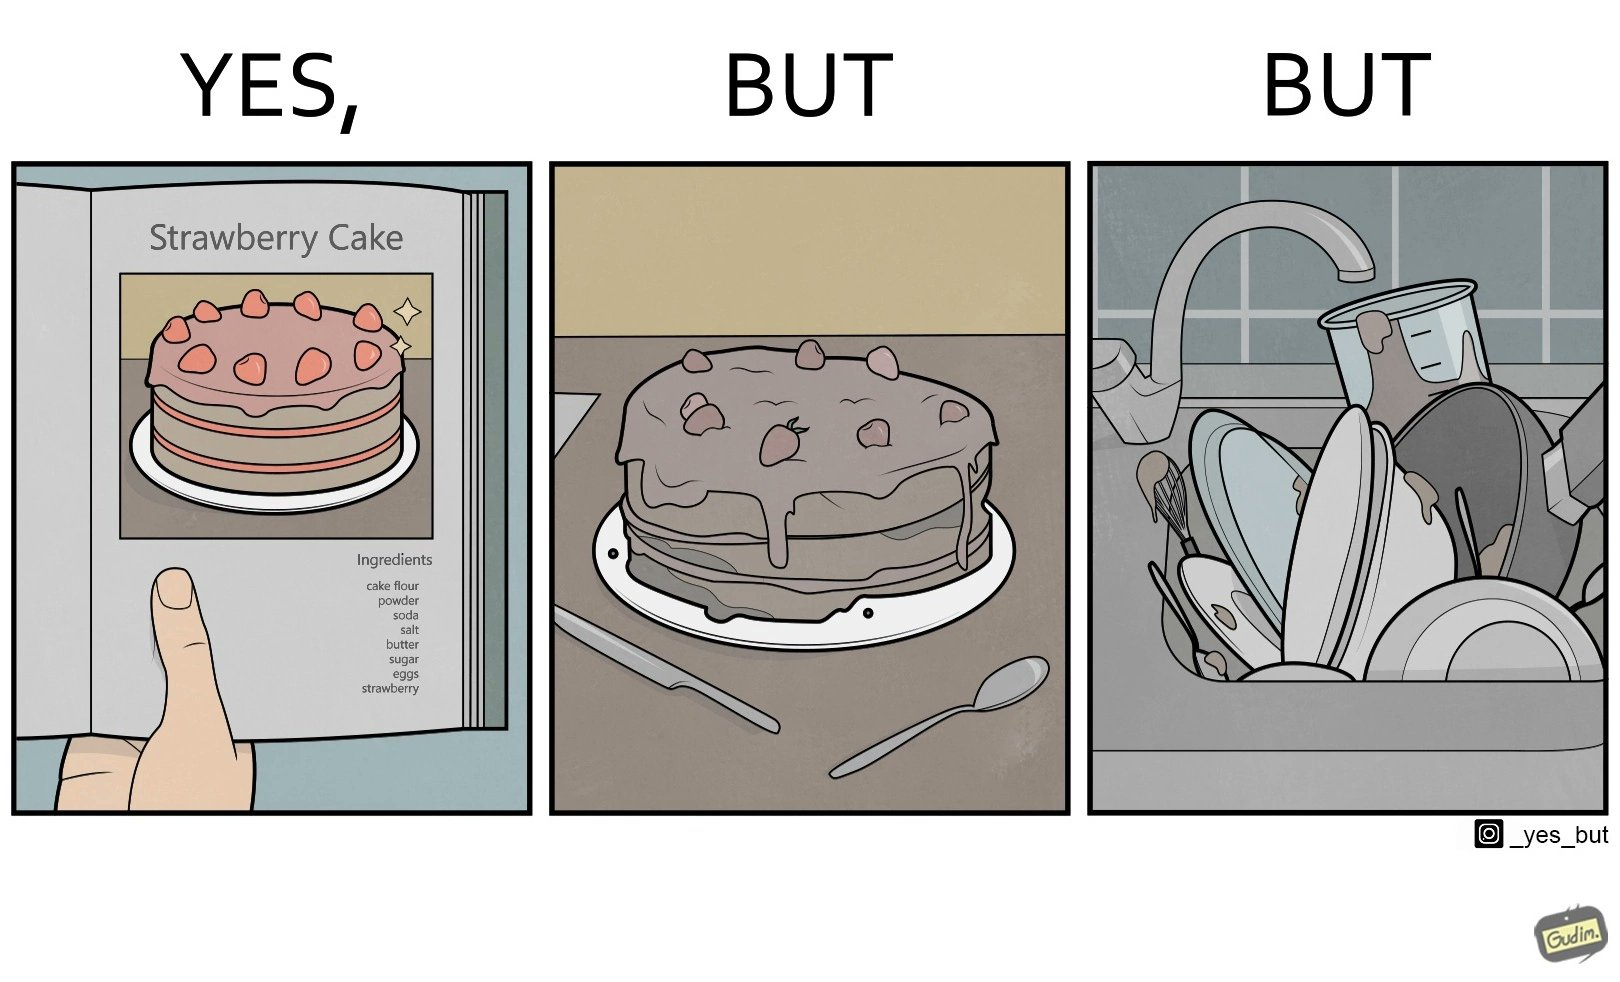Is this image satirical or non-satirical? Yes, this image is satirical. 